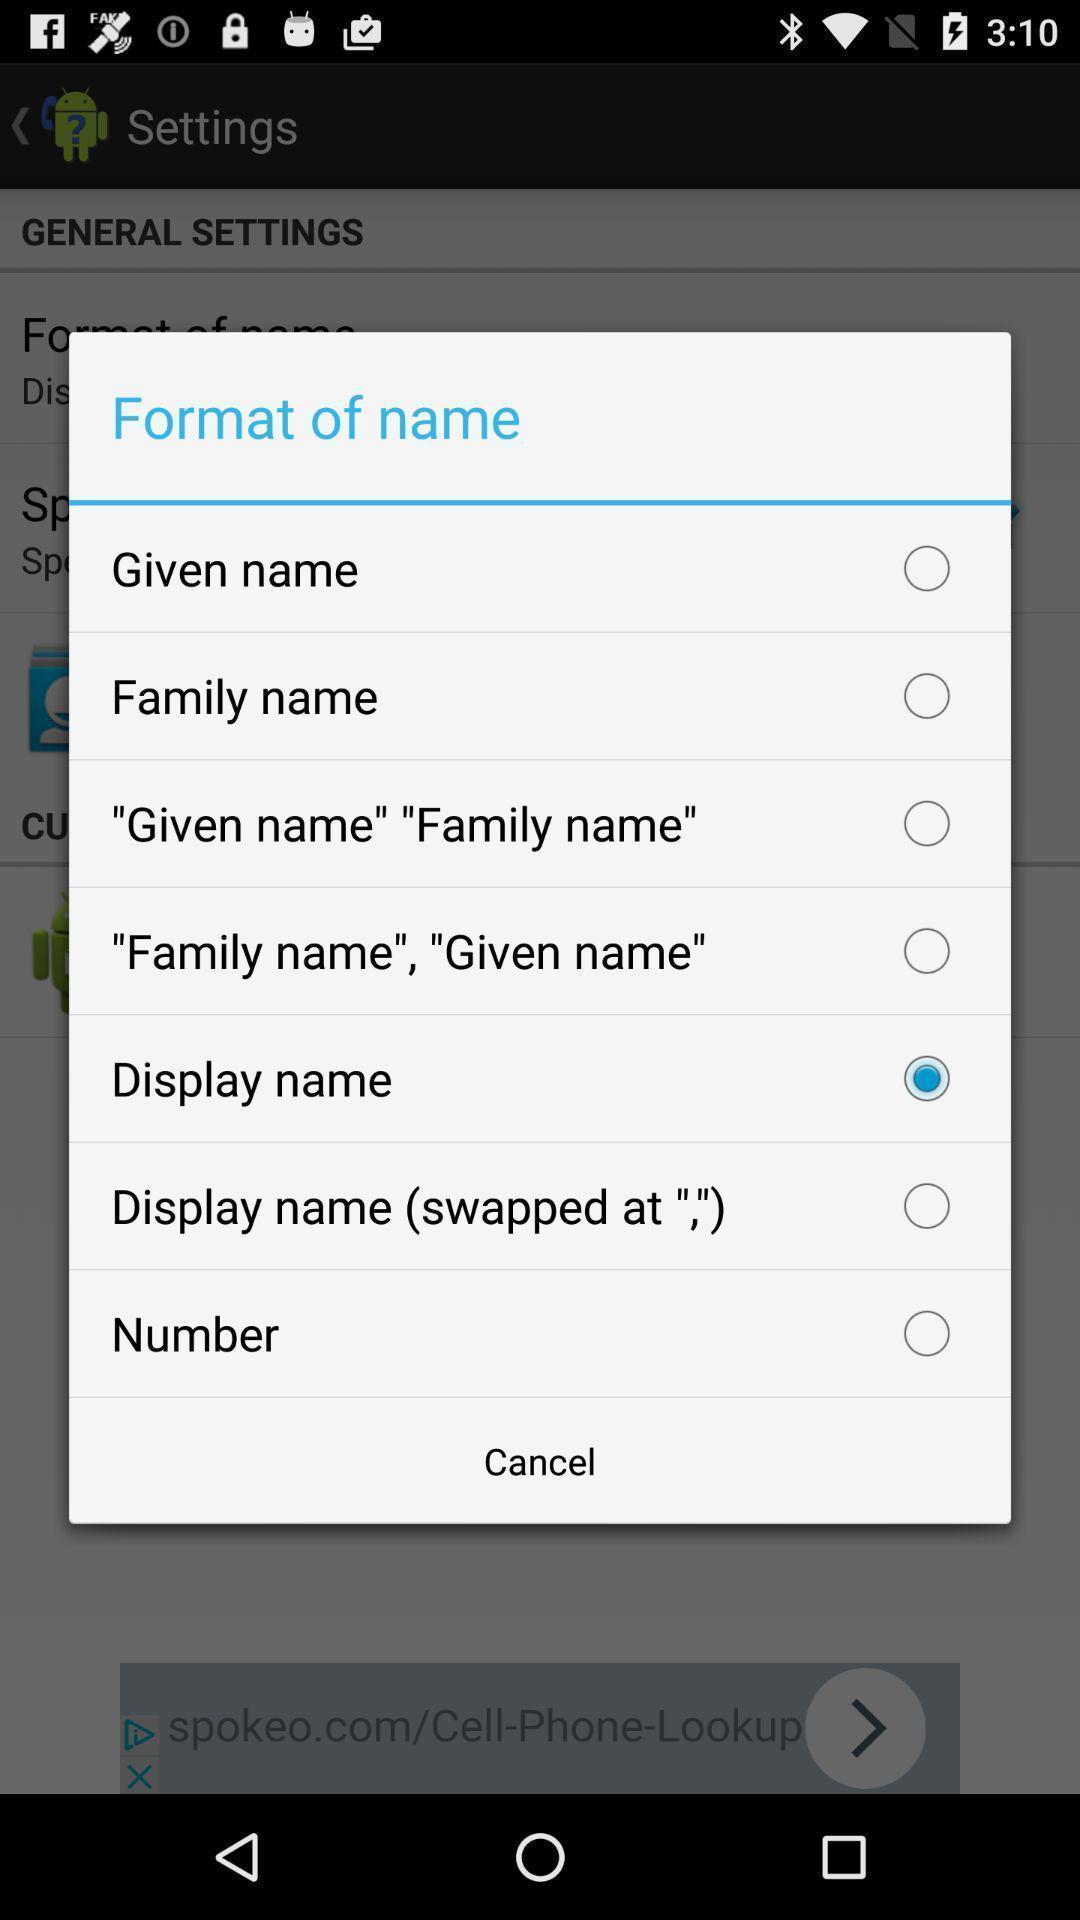Describe the content in this image. Popup displaying options to choose. 